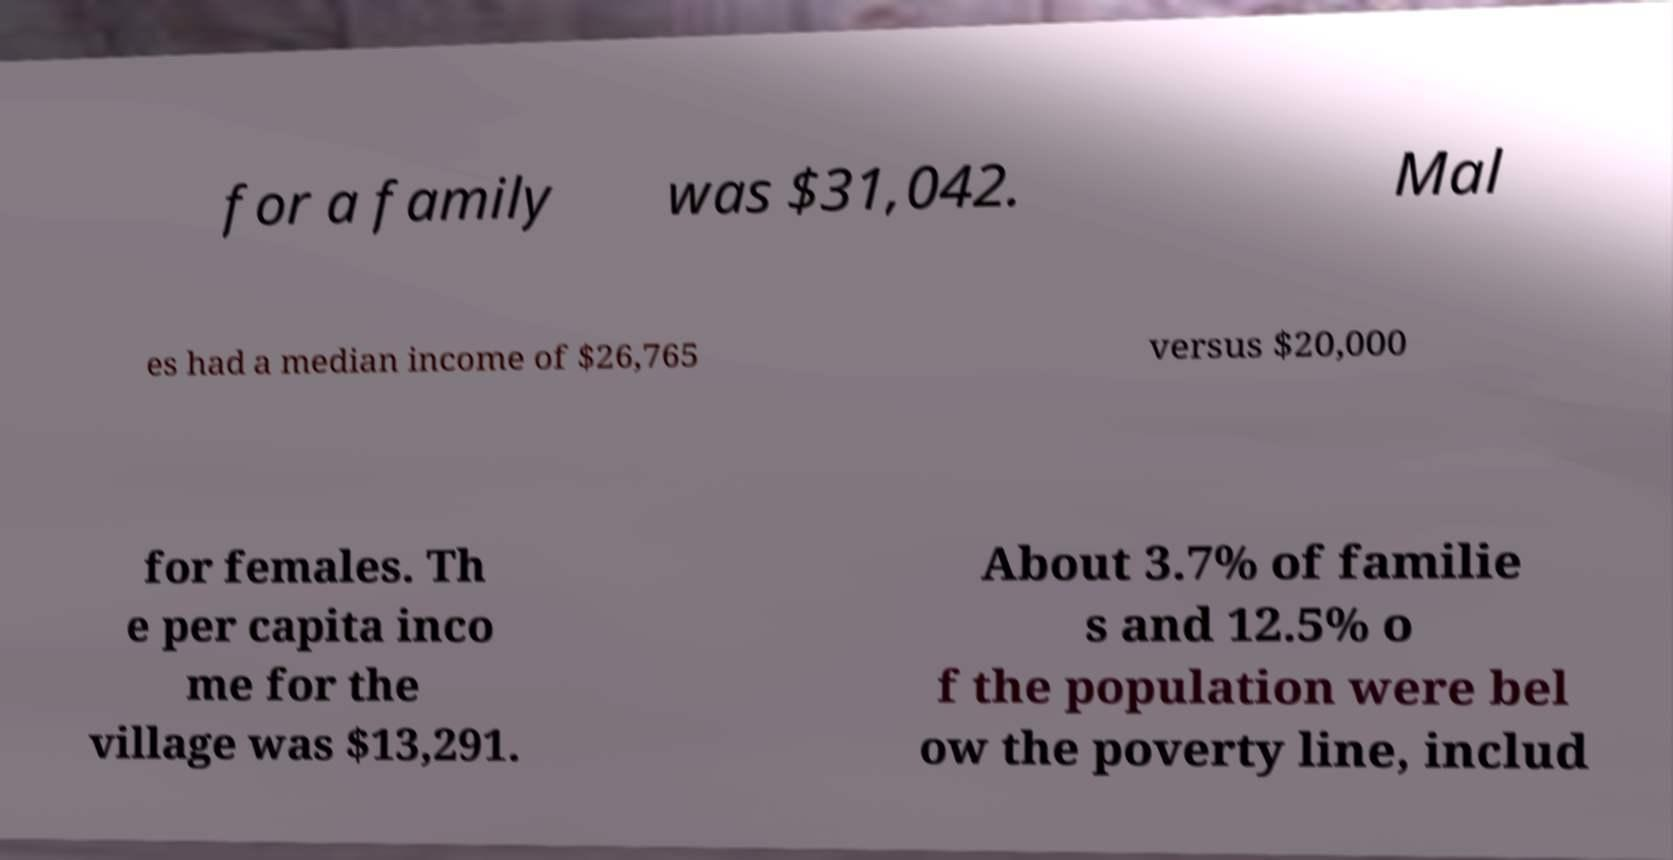For documentation purposes, I need the text within this image transcribed. Could you provide that? for a family was $31,042. Mal es had a median income of $26,765 versus $20,000 for females. Th e per capita inco me for the village was $13,291. About 3.7% of familie s and 12.5% o f the population were bel ow the poverty line, includ 